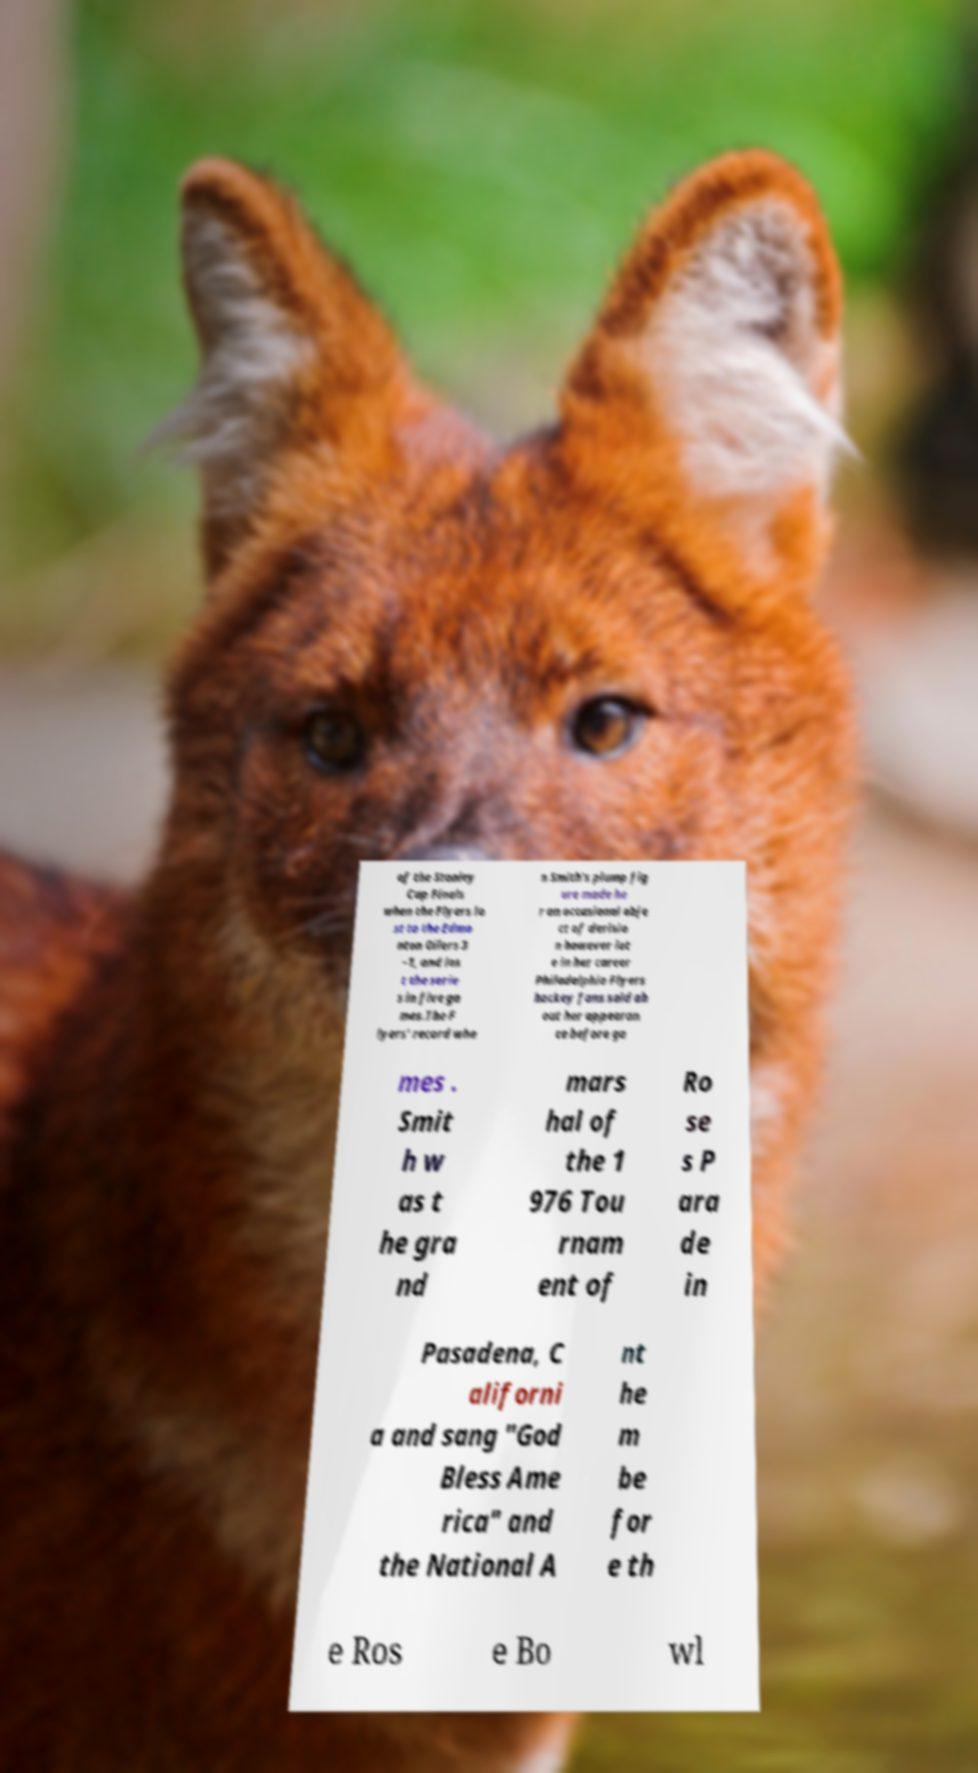I need the written content from this picture converted into text. Can you do that? of the Stanley Cup Finals when the Flyers lo st to the Edmo nton Oilers 3 –1, and los t the serie s in five ga mes.The F lyers' record whe n Smith's plump fig ure made he r an occasional obje ct of derisio n however lat e in her career Philadelphia Flyers hockey fans said ab out her appearan ce before ga mes . Smit h w as t he gra nd mars hal of the 1 976 Tou rnam ent of Ro se s P ara de in Pasadena, C aliforni a and sang "God Bless Ame rica" and the National A nt he m be for e th e Ros e Bo wl 